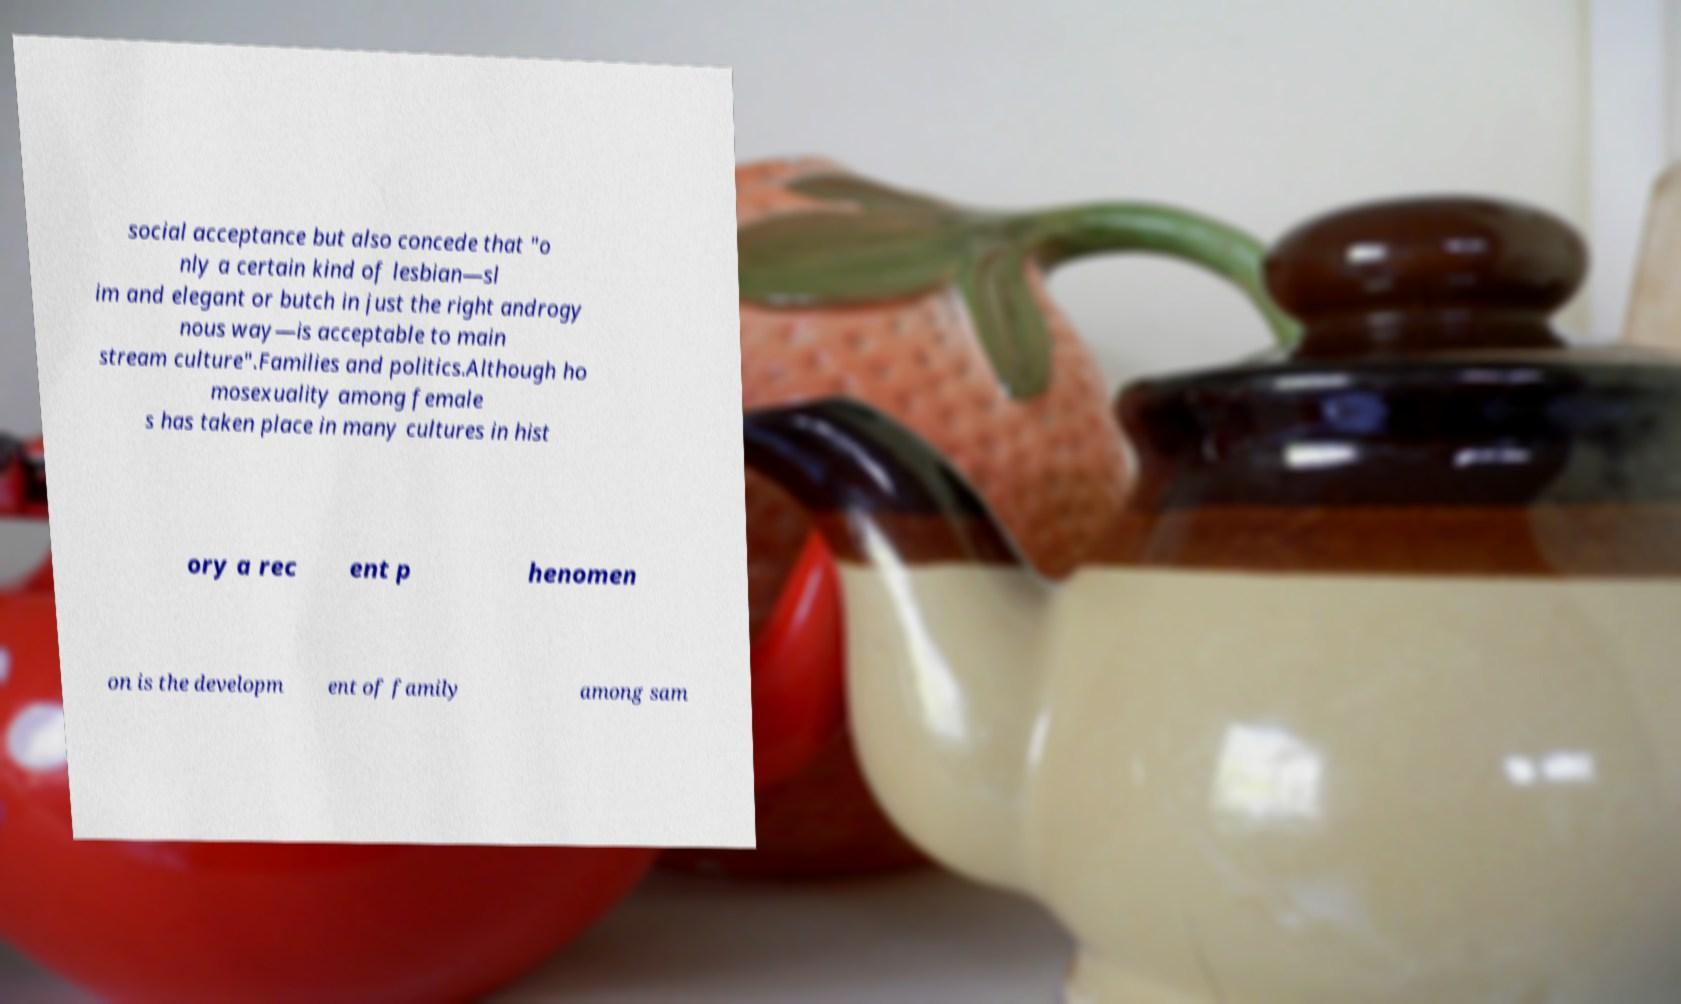Can you read and provide the text displayed in the image?This photo seems to have some interesting text. Can you extract and type it out for me? social acceptance but also concede that "o nly a certain kind of lesbian—sl im and elegant or butch in just the right androgy nous way—is acceptable to main stream culture".Families and politics.Although ho mosexuality among female s has taken place in many cultures in hist ory a rec ent p henomen on is the developm ent of family among sam 